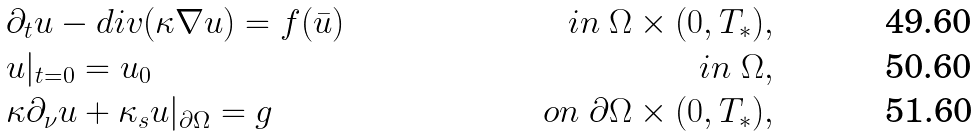Convert formula to latex. <formula><loc_0><loc_0><loc_500><loc_500>& \partial _ { t } u - d i v ( \kappa \nabla u ) = f ( \bar { u } ) & i n \ \Omega \times ( 0 , T _ { * } ) , \\ & u | _ { t = 0 } = u _ { 0 } & i n \ \Omega , \\ & \kappa \partial _ { \nu } u + \kappa _ { s } u | _ { \partial \Omega } = g & o n \ \partial \Omega \times ( 0 , T _ { * } ) ,</formula> 